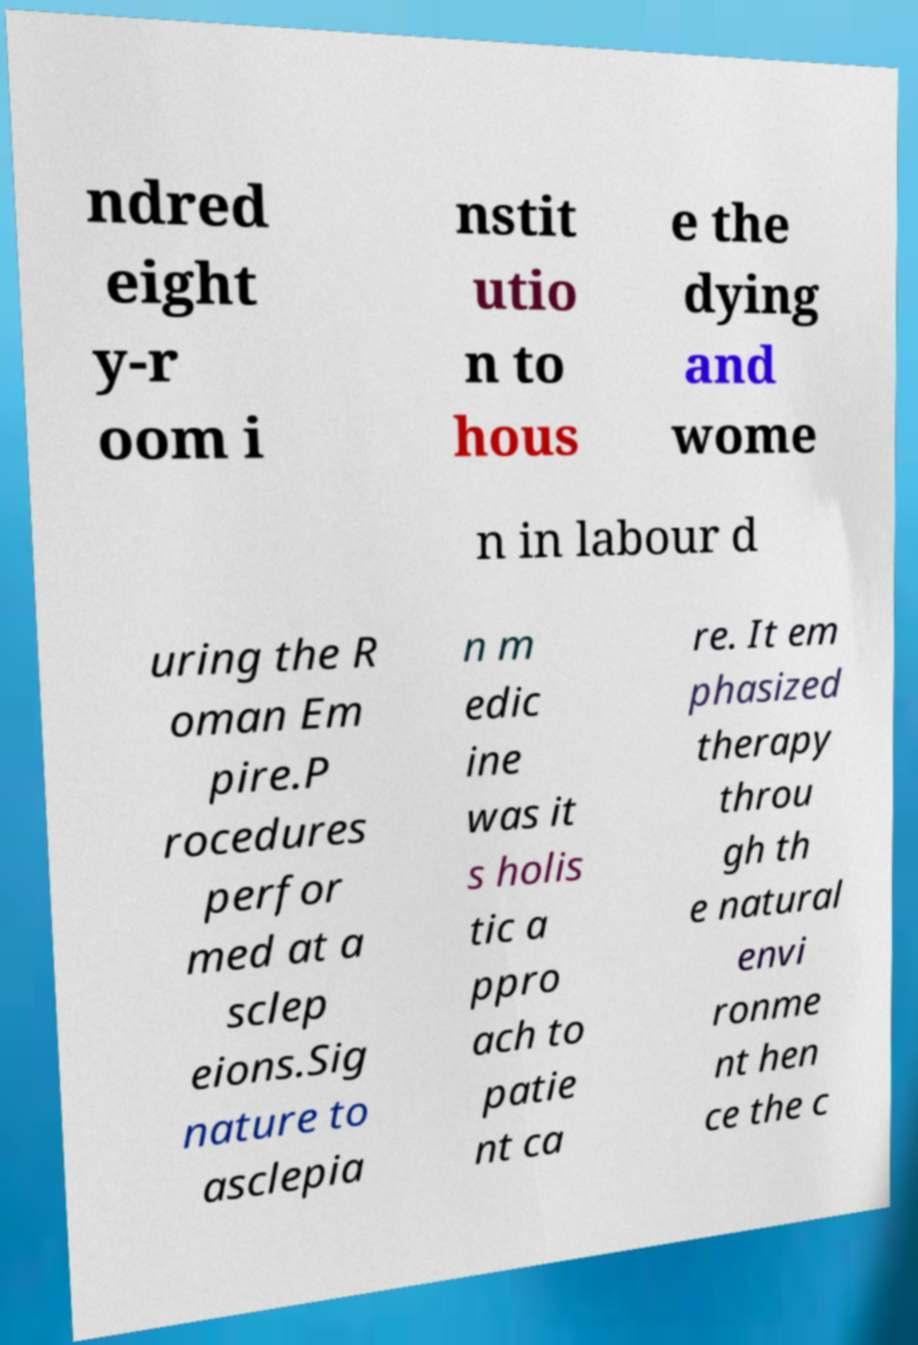Can you accurately transcribe the text from the provided image for me? ndred eight y-r oom i nstit utio n to hous e the dying and wome n in labour d uring the R oman Em pire.P rocedures perfor med at a sclep eions.Sig nature to asclepia n m edic ine was it s holis tic a ppro ach to patie nt ca re. It em phasized therapy throu gh th e natural envi ronme nt hen ce the c 